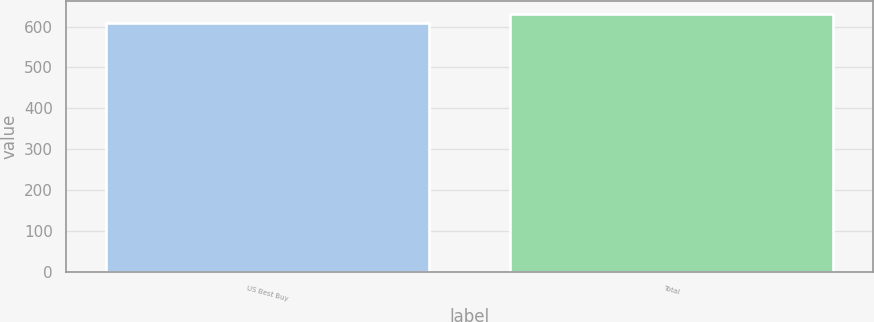<chart> <loc_0><loc_0><loc_500><loc_500><bar_chart><fcel>US Best Buy<fcel>Total<nl><fcel>608<fcel>631<nl></chart> 